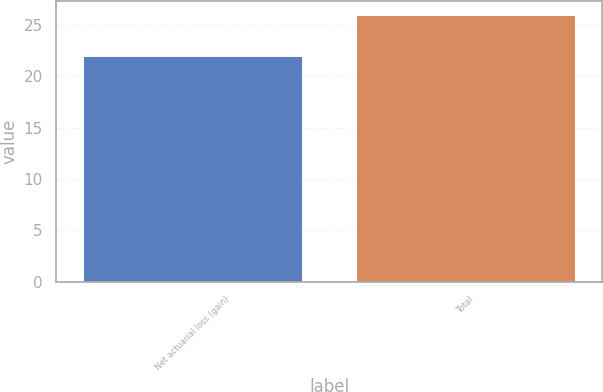Convert chart. <chart><loc_0><loc_0><loc_500><loc_500><bar_chart><fcel>Net actuarial loss (gain)<fcel>Total<nl><fcel>22<fcel>26<nl></chart> 